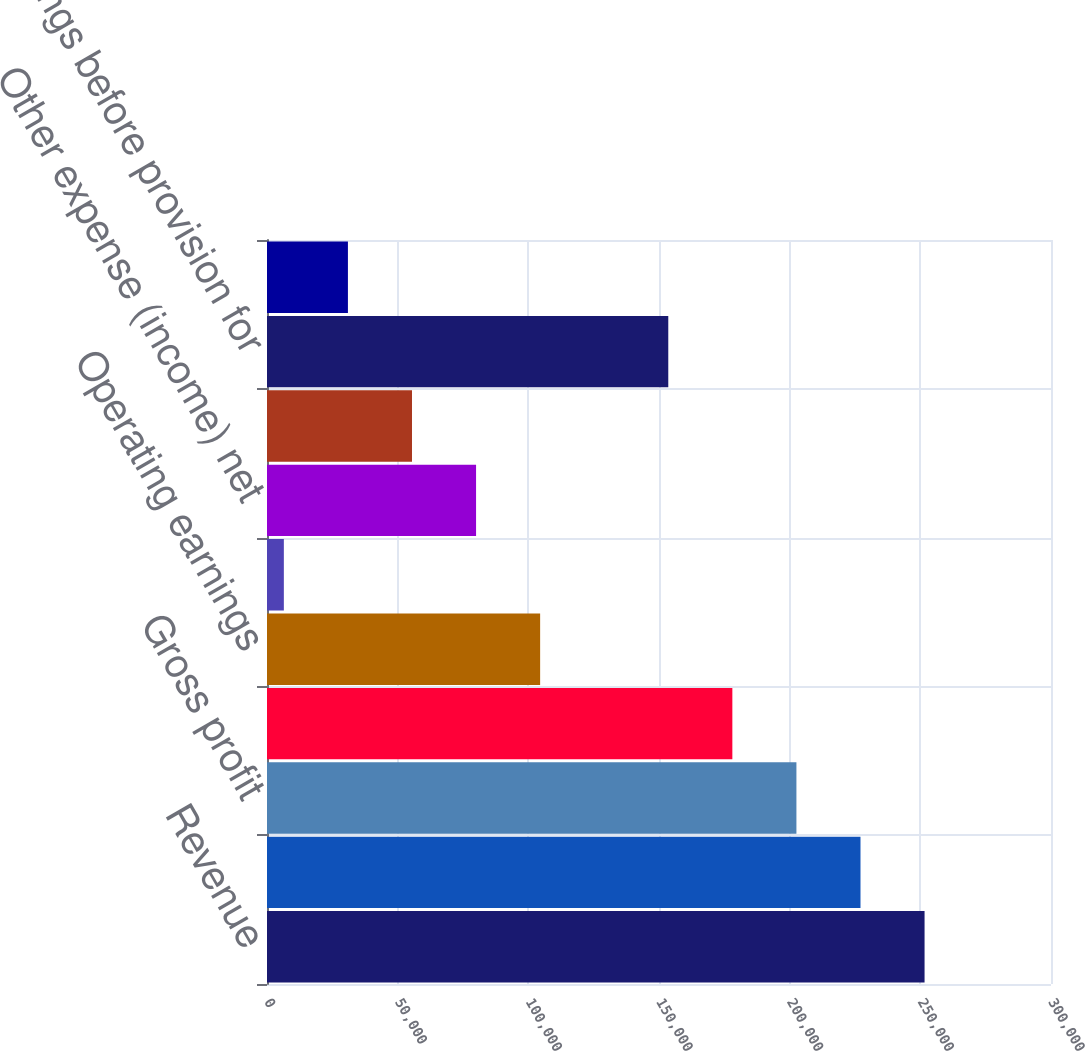<chart> <loc_0><loc_0><loc_500><loc_500><bar_chart><fcel>Revenue<fcel>Cost of goods and services<fcel>Gross profit<fcel>Selling and administrative<fcel>Operating earnings<fcel>Interest expense net<fcel>Other expense (income) net<fcel>Total interest/other expense<fcel>Earnings before provision for<fcel>Provision for income taxes<nl><fcel>251618<fcel>227101<fcel>202584<fcel>178067<fcel>104516<fcel>6448<fcel>79999<fcel>55482<fcel>153550<fcel>30965<nl></chart> 